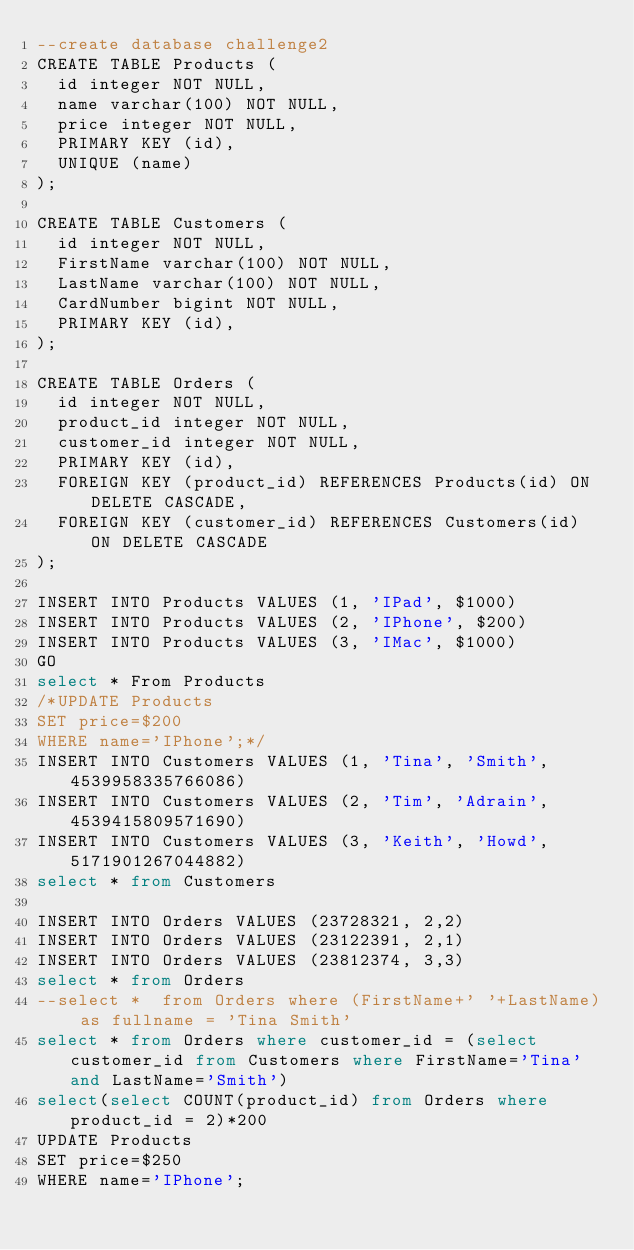<code> <loc_0><loc_0><loc_500><loc_500><_SQL_>--create database challenge2
CREATE TABLE Products (
  id integer NOT NULL,
  name varchar(100) NOT NULL,
  price integer NOT NULL,
  PRIMARY KEY (id),
  UNIQUE (name)
);

CREATE TABLE Customers (
  id integer NOT NULL,
  FirstName varchar(100) NOT NULL,
  LastName varchar(100) NOT NULL,
  CardNumber bigint NOT NULL,
  PRIMARY KEY (id),
);

CREATE TABLE Orders (
  id integer NOT NULL,
  product_id integer NOT NULL,
  customer_id integer NOT NULL,
  PRIMARY KEY (id),
  FOREIGN KEY (product_id) REFERENCES Products(id) ON DELETE CASCADE,
  FOREIGN KEY (customer_id) REFERENCES Customers(id) ON DELETE CASCADE
);

INSERT INTO Products VALUES (1, 'IPad', $1000)
INSERT INTO Products VALUES (2, 'IPhone', $200)
INSERT INTO Products VALUES (3, 'IMac', $1000)
GO
select * From Products
/*UPDATE Products
SET price=$200
WHERE name='IPhone';*/
INSERT INTO Customers VALUES (1, 'Tina', 'Smith', 4539958335766086)
INSERT INTO Customers VALUES (2, 'Tim', 'Adrain', 4539415809571690)
INSERT INTO Customers VALUES (3, 'Keith', 'Howd', 5171901267044882)
select * from Customers

INSERT INTO Orders VALUES (23728321, 2,2)
INSERT INTO Orders VALUES (23122391, 2,1)
INSERT INTO Orders VALUES (23812374, 3,3)
select * from Orders
--select *  from Orders where (FirstName+' '+LastName) as fullname = 'Tina Smith'
select * from Orders where customer_id = (select customer_id from Customers where FirstName='Tina' and LastName='Smith')
select(select COUNT(product_id) from Orders where product_id = 2)*200
UPDATE Products
SET price=$250
WHERE name='IPhone';</code> 